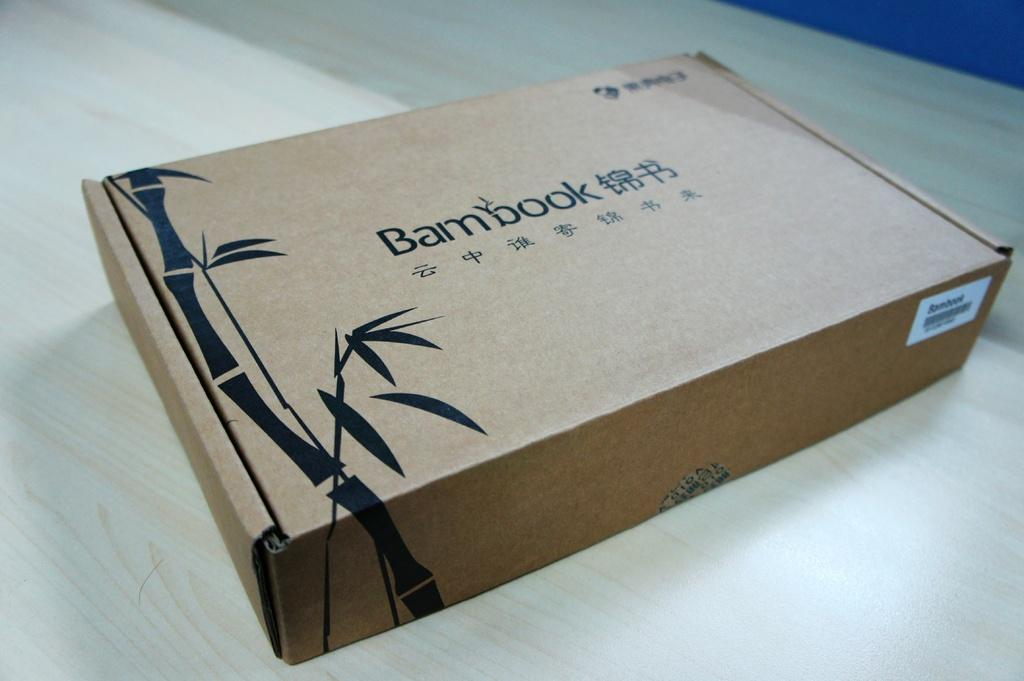<image>
Give a short and clear explanation of the subsequent image. A Bambook cardboard box is resting on a wooden table 